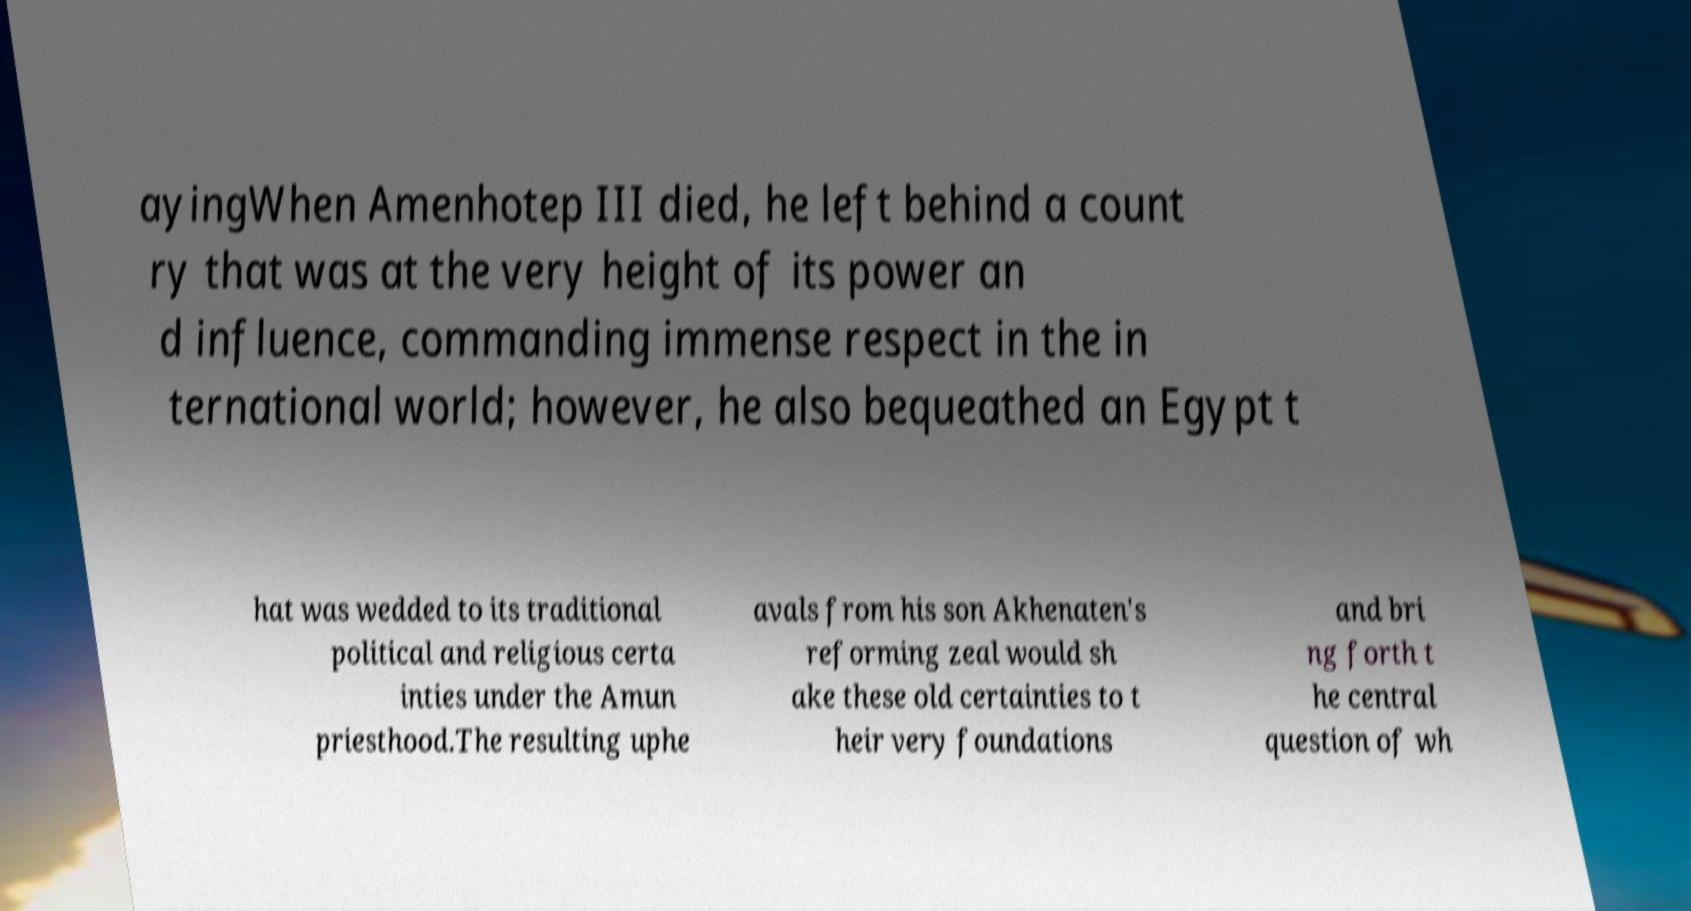Could you extract and type out the text from this image? ayingWhen Amenhotep III died, he left behind a count ry that was at the very height of its power an d influence, commanding immense respect in the in ternational world; however, he also bequeathed an Egypt t hat was wedded to its traditional political and religious certa inties under the Amun priesthood.The resulting uphe avals from his son Akhenaten's reforming zeal would sh ake these old certainties to t heir very foundations and bri ng forth t he central question of wh 